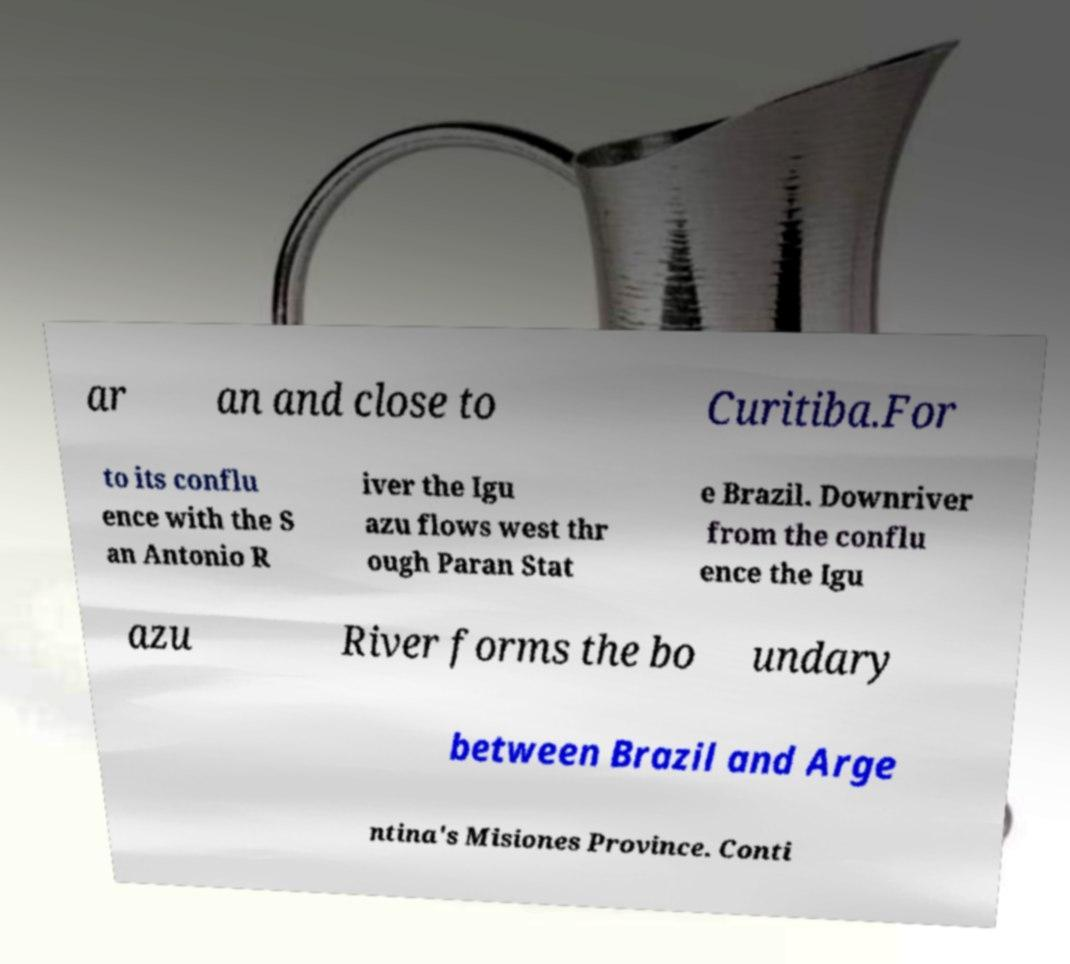Can you read and provide the text displayed in the image?This photo seems to have some interesting text. Can you extract and type it out for me? ar an and close to Curitiba.For to its conflu ence with the S an Antonio R iver the Igu azu flows west thr ough Paran Stat e Brazil. Downriver from the conflu ence the Igu azu River forms the bo undary between Brazil and Arge ntina's Misiones Province. Conti 